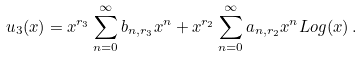Convert formula to latex. <formula><loc_0><loc_0><loc_500><loc_500>u _ { 3 } ( x ) = x ^ { r _ { 3 } } \sum _ { n = 0 } ^ { \infty } b _ { n , r _ { 3 } } x ^ { n } + x ^ { r _ { 2 } } \sum _ { n = 0 } ^ { \infty } a _ { n , r _ { 2 } } x ^ { n } L o g ( x ) \, .</formula> 